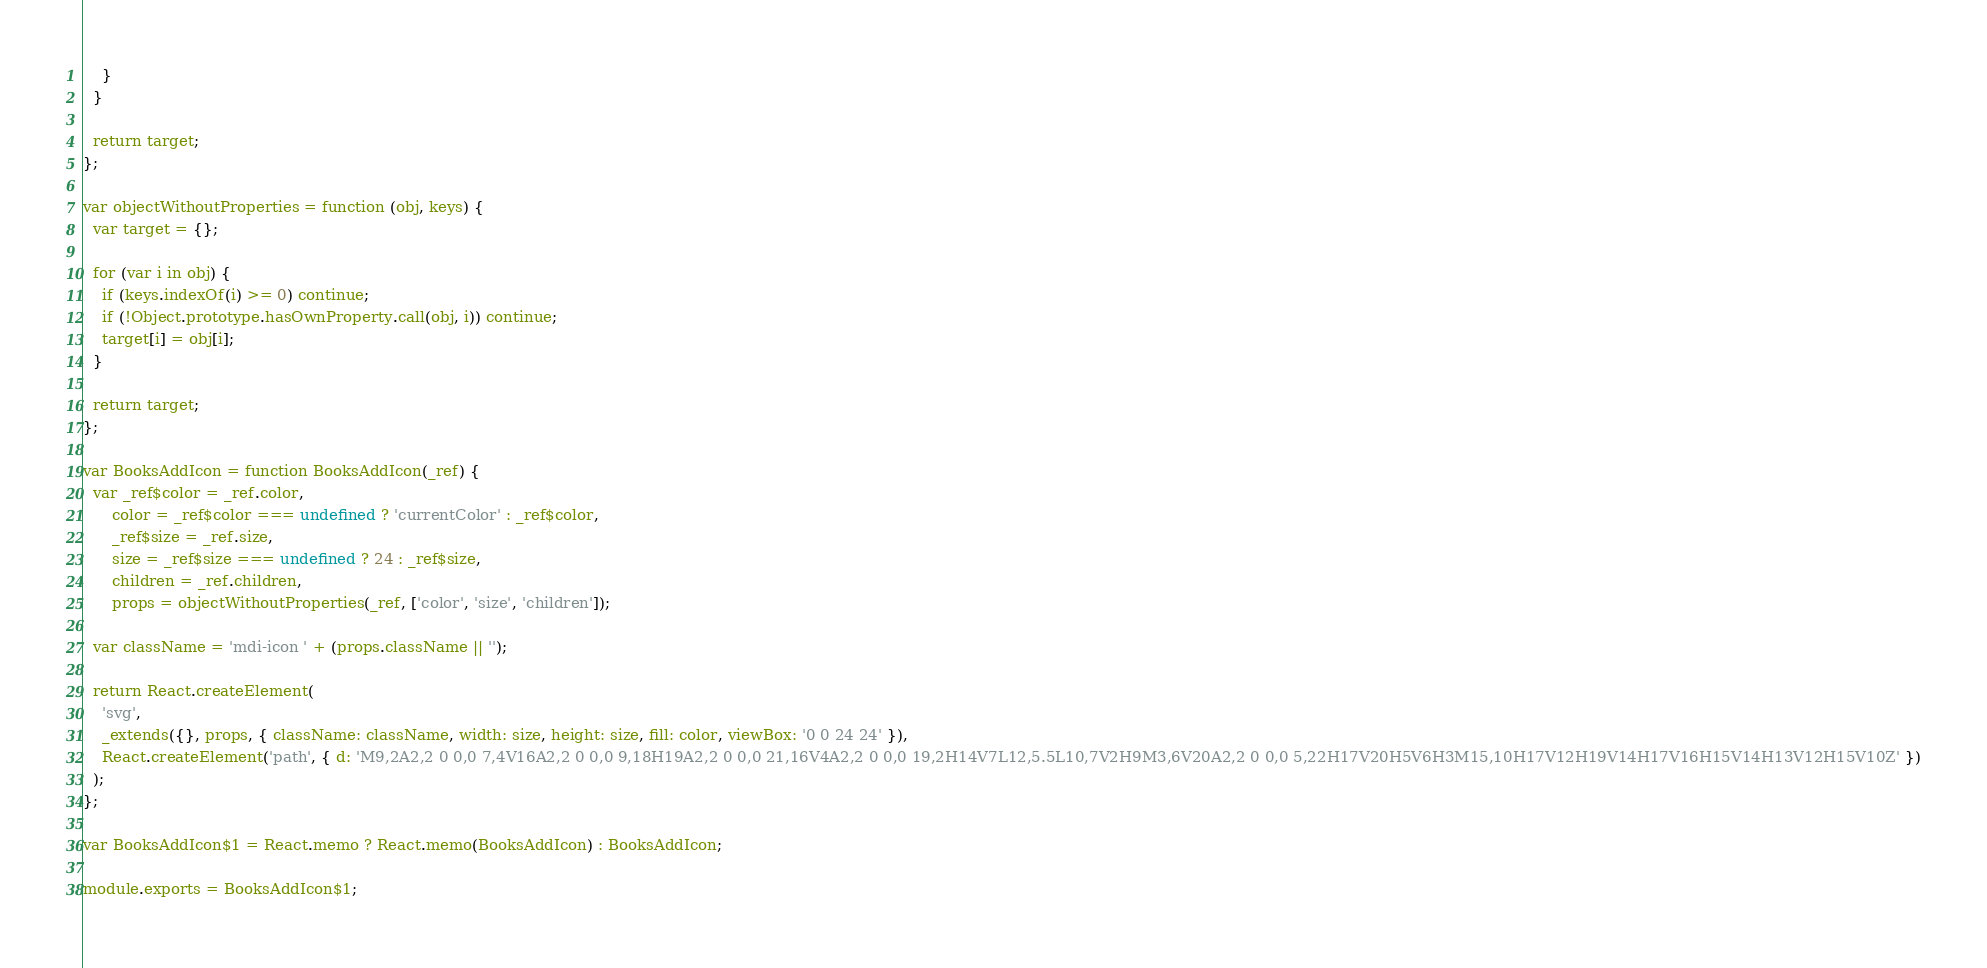Convert code to text. <code><loc_0><loc_0><loc_500><loc_500><_JavaScript_>    }
  }

  return target;
};

var objectWithoutProperties = function (obj, keys) {
  var target = {};

  for (var i in obj) {
    if (keys.indexOf(i) >= 0) continue;
    if (!Object.prototype.hasOwnProperty.call(obj, i)) continue;
    target[i] = obj[i];
  }

  return target;
};

var BooksAddIcon = function BooksAddIcon(_ref) {
  var _ref$color = _ref.color,
      color = _ref$color === undefined ? 'currentColor' : _ref$color,
      _ref$size = _ref.size,
      size = _ref$size === undefined ? 24 : _ref$size,
      children = _ref.children,
      props = objectWithoutProperties(_ref, ['color', 'size', 'children']);

  var className = 'mdi-icon ' + (props.className || '');

  return React.createElement(
    'svg',
    _extends({}, props, { className: className, width: size, height: size, fill: color, viewBox: '0 0 24 24' }),
    React.createElement('path', { d: 'M9,2A2,2 0 0,0 7,4V16A2,2 0 0,0 9,18H19A2,2 0 0,0 21,16V4A2,2 0 0,0 19,2H14V7L12,5.5L10,7V2H9M3,6V20A2,2 0 0,0 5,22H17V20H5V6H3M15,10H17V12H19V14H17V16H15V14H13V12H15V10Z' })
  );
};

var BooksAddIcon$1 = React.memo ? React.memo(BooksAddIcon) : BooksAddIcon;

module.exports = BooksAddIcon$1;
</code> 